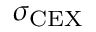Convert formula to latex. <formula><loc_0><loc_0><loc_500><loc_500>\sigma _ { C E X }</formula> 